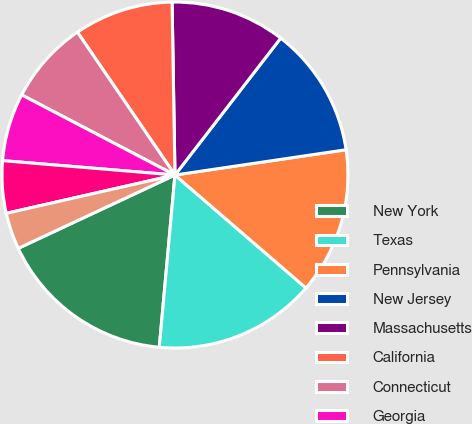Convert chart. <chart><loc_0><loc_0><loc_500><loc_500><pie_chart><fcel>New York<fcel>Texas<fcel>Pennsylvania<fcel>New Jersey<fcel>Massachusetts<fcel>California<fcel>Connecticut<fcel>Georgia<fcel>Virginia<fcel>Florida<nl><fcel>16.59%<fcel>15.12%<fcel>13.66%<fcel>12.2%<fcel>10.73%<fcel>9.27%<fcel>7.8%<fcel>6.34%<fcel>4.88%<fcel>3.41%<nl></chart> 